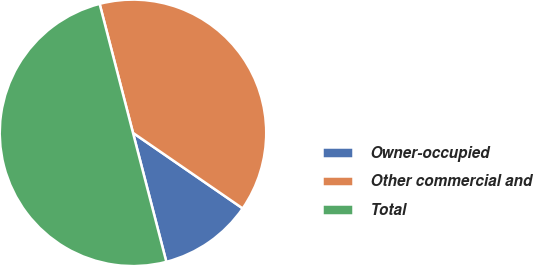<chart> <loc_0><loc_0><loc_500><loc_500><pie_chart><fcel>Owner-occupied<fcel>Other commercial and<fcel>Total<nl><fcel>11.37%<fcel>38.63%<fcel>50.0%<nl></chart> 